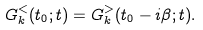<formula> <loc_0><loc_0><loc_500><loc_500>G _ { k } ^ { < } ( t _ { 0 } ; t ) = G _ { k } ^ { > } ( t _ { 0 } - i \beta ; t ) .</formula> 